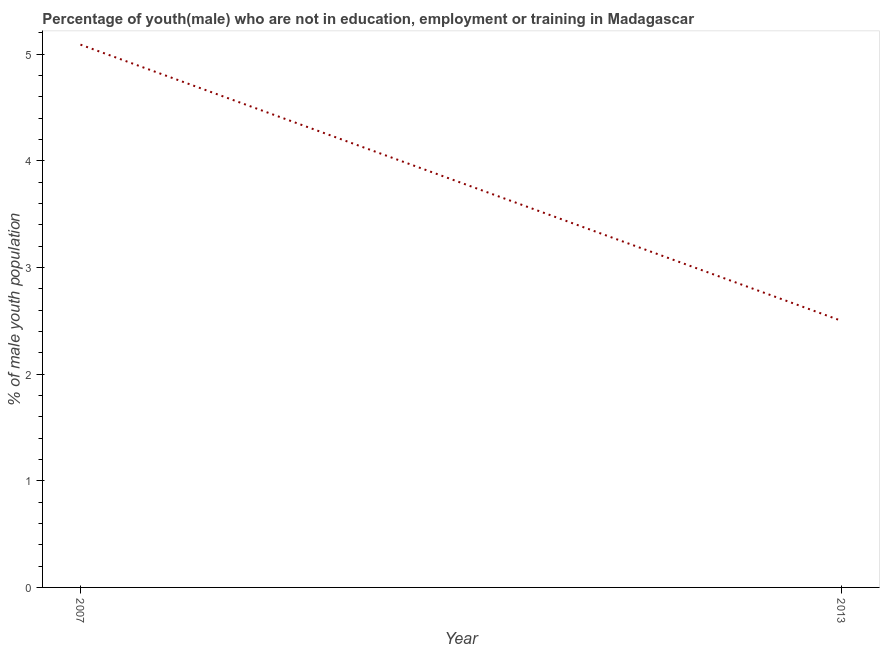What is the unemployed male youth population in 2007?
Make the answer very short. 5.09. Across all years, what is the maximum unemployed male youth population?
Ensure brevity in your answer.  5.09. In which year was the unemployed male youth population maximum?
Offer a very short reply. 2007. What is the sum of the unemployed male youth population?
Offer a terse response. 7.59. What is the difference between the unemployed male youth population in 2007 and 2013?
Provide a short and direct response. 2.59. What is the average unemployed male youth population per year?
Your answer should be very brief. 3.8. What is the median unemployed male youth population?
Provide a succinct answer. 3.8. Do a majority of the years between 2013 and 2007 (inclusive) have unemployed male youth population greater than 2 %?
Provide a succinct answer. No. What is the ratio of the unemployed male youth population in 2007 to that in 2013?
Keep it short and to the point. 2.04. How many lines are there?
Your answer should be compact. 1. What is the difference between two consecutive major ticks on the Y-axis?
Give a very brief answer. 1. Does the graph contain any zero values?
Keep it short and to the point. No. What is the title of the graph?
Ensure brevity in your answer.  Percentage of youth(male) who are not in education, employment or training in Madagascar. What is the label or title of the X-axis?
Make the answer very short. Year. What is the label or title of the Y-axis?
Keep it short and to the point. % of male youth population. What is the % of male youth population of 2007?
Your answer should be very brief. 5.09. What is the % of male youth population of 2013?
Give a very brief answer. 2.5. What is the difference between the % of male youth population in 2007 and 2013?
Provide a short and direct response. 2.59. What is the ratio of the % of male youth population in 2007 to that in 2013?
Offer a terse response. 2.04. 